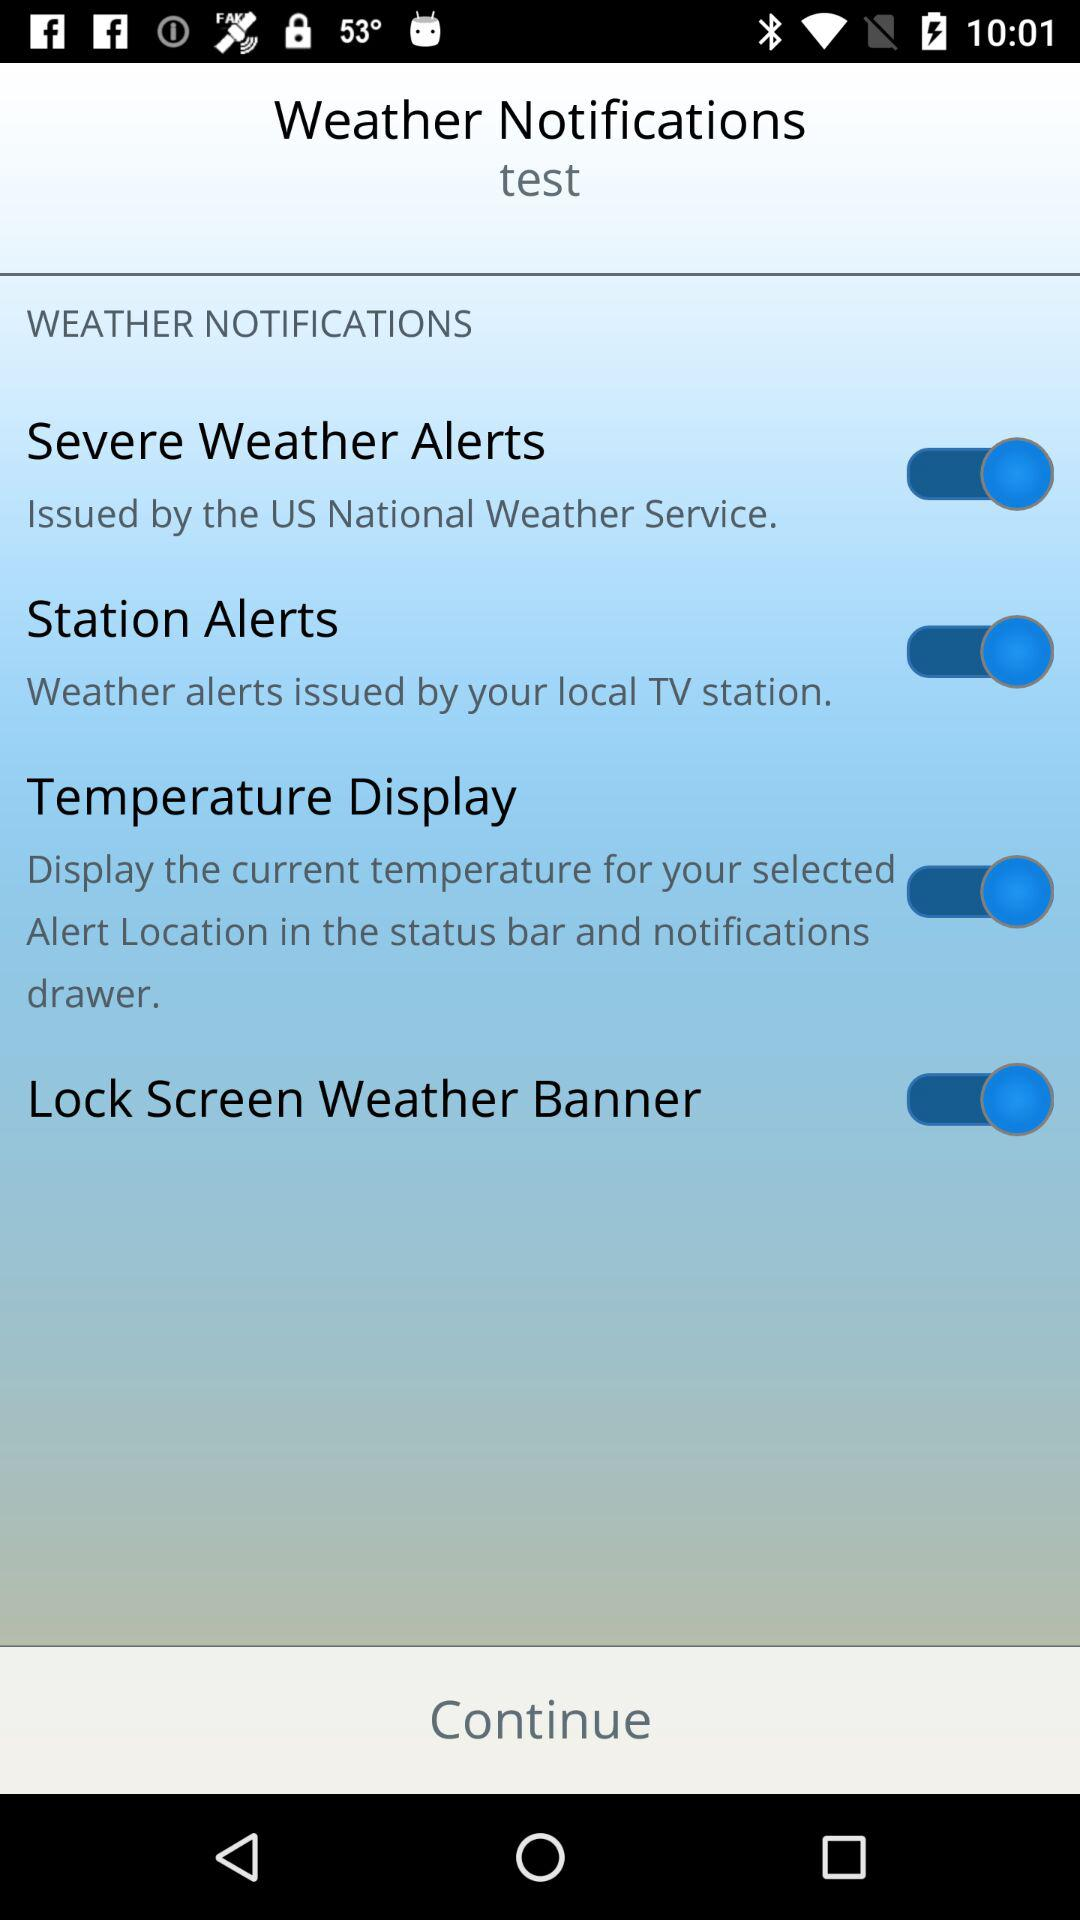How many settings are available for the weather notifications?
Answer the question using a single word or phrase. 4 